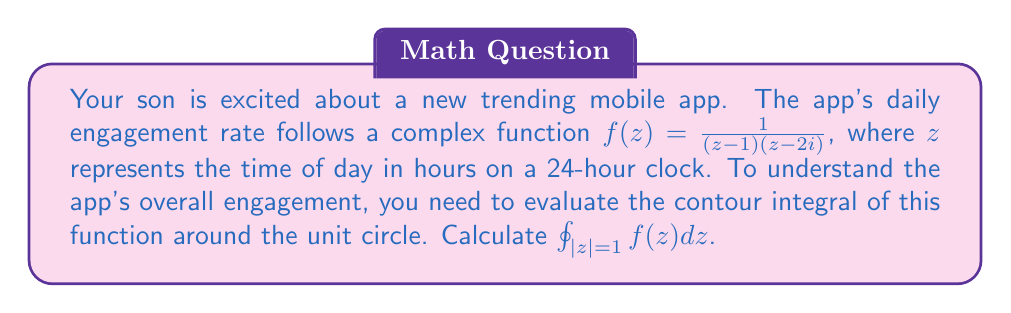Give your solution to this math problem. Let's approach this step-by-step using the residue theorem:

1) The residue theorem states that for a complex function $f(z)$ that is analytic on and inside a simple closed contour $C$, except for a finite number of singular points inside $C$:

   $$\oint_C f(z) dz = 2\pi i \sum \text{Res}(f, a_k)$$

   where $a_k$ are the singular points of $f(z)$ inside $C$.

2) In our case, $C$ is the unit circle $|z|=1$, and $f(z) = \frac{1}{(z-1)(z-2i)}$.

3) We need to find the singular points (poles) of $f(z)$ inside the unit circle. These are:
   - $z = 1$ (on the contour, we'll consider it)
   - $z = 2i$ (outside the unit circle, we'll ignore it)

4) We only need to calculate the residue at $z = 1$:

   $$\text{Res}(f, 1) = \lim_{z \to 1} (z-1)f(z) = \lim_{z \to 1} \frac{1}{z-2i} = \frac{1}{1-2i}$$

5) Now we can apply the residue theorem:

   $$\oint_{|z|=1} f(z) dz = 2\pi i \cdot \frac{1}{1-2i}$$

6) To simplify this, multiply numerator and denominator by the complex conjugate of the denominator:

   $$2\pi i \cdot \frac{1}{1-2i} \cdot \frac{1+2i}{1+2i} = 2\pi i \cdot \frac{1+2i}{1+4} = 2\pi i \cdot \frac{1+2i}{5}$$

7) Separating real and imaginary parts:

   $$2\pi i \cdot (\frac{1}{5} + \frac{2i}{5}) = \frac{2\pi}{5} - \frac{4\pi i}{5}$$
Answer: $$\frac{2\pi}{5} - \frac{4\pi i}{5}$$ 